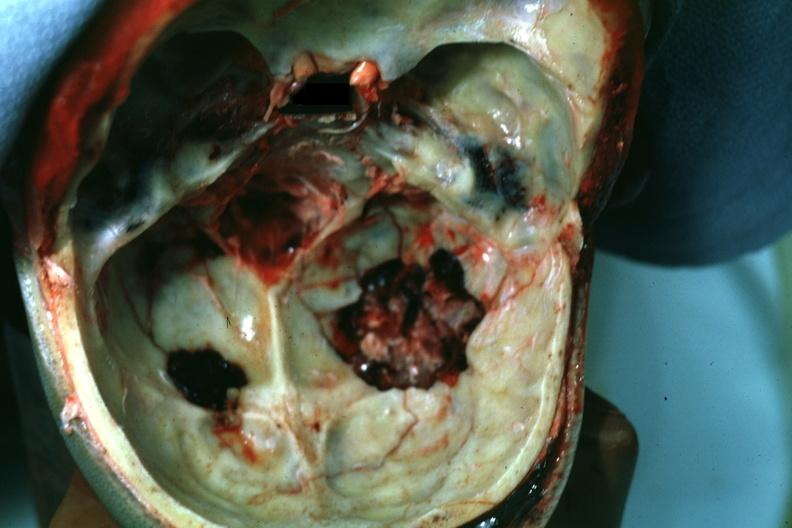s basilar skull fracture present?
Answer the question using a single word or phrase. Yes 